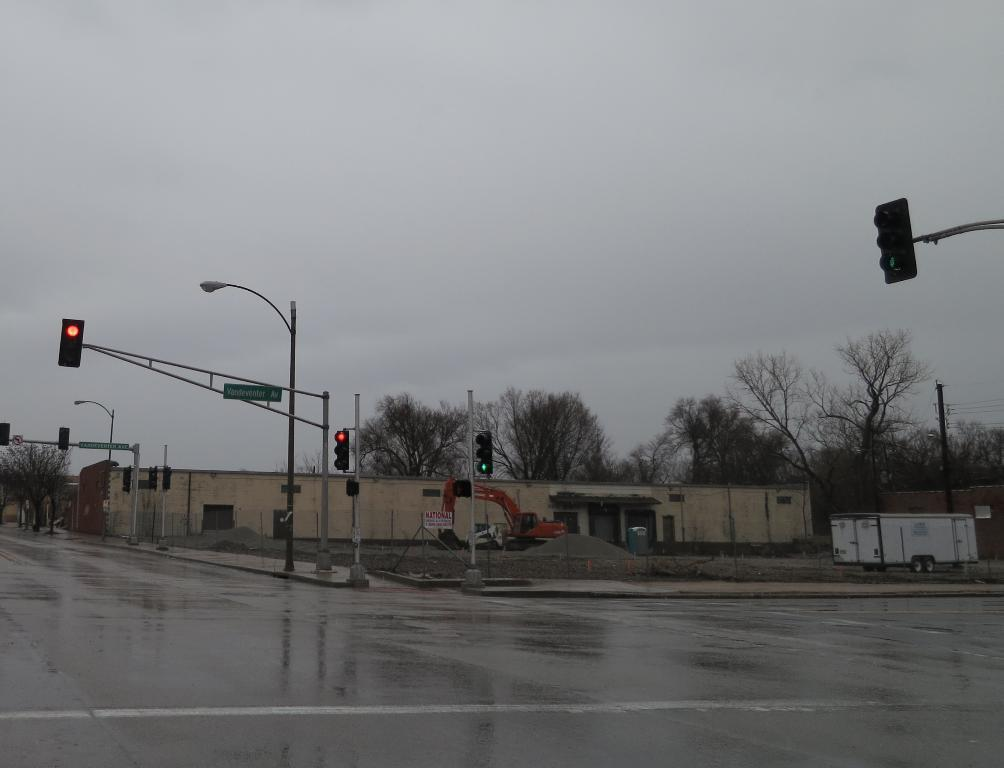What is the condition of the road in the image? The road is wet in the image. What objects can be seen along the road? There are poles and traffic signals in the image. What can be seen in the background of the image? There are buildings and trees in the background of the image. Can you see any steam coming from the bit in the image? There is no bit or steam present in the image. What type of hook is attached to the traffic signal in the image? There is no hook attached to the traffic signal in the image; it is a standard traffic signal. 